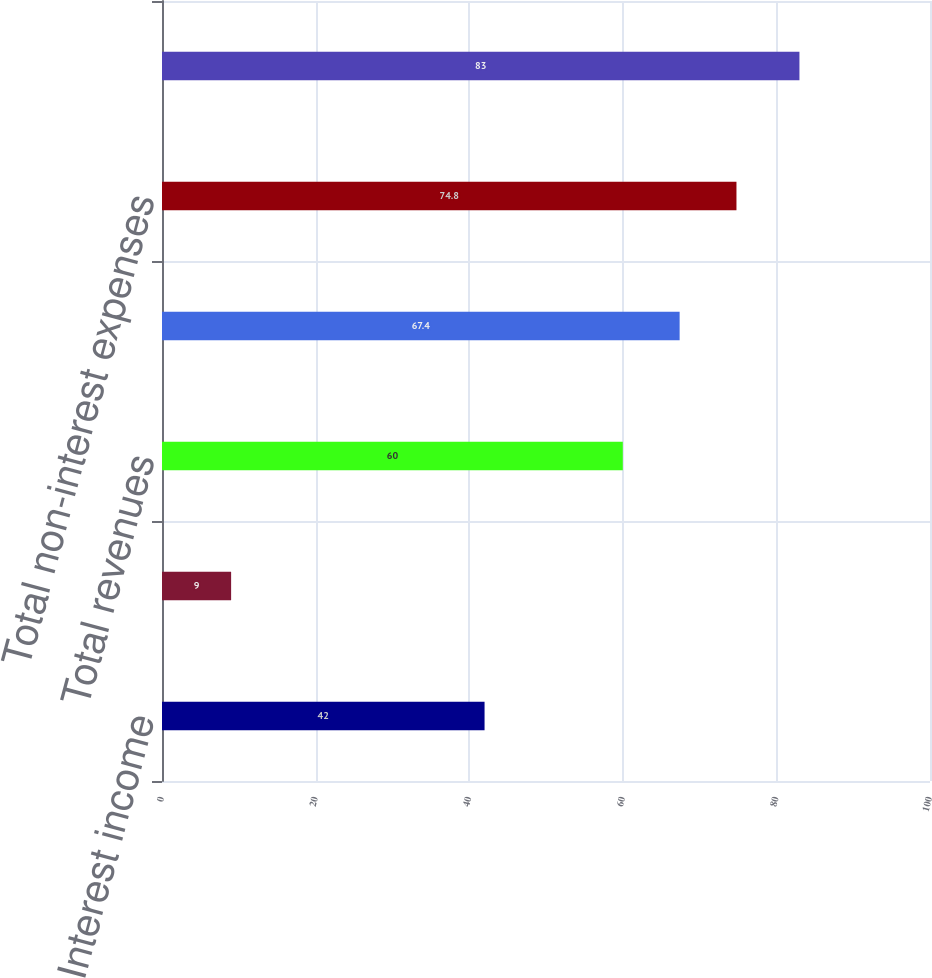<chart> <loc_0><loc_0><loc_500><loc_500><bar_chart><fcel>Interest income<fcel>Gains on private equity<fcel>Total revenues<fcel>Compensation and all other<fcel>Total non-interest expenses<fcel>Pre-tax loss<nl><fcel>42<fcel>9<fcel>60<fcel>67.4<fcel>74.8<fcel>83<nl></chart> 